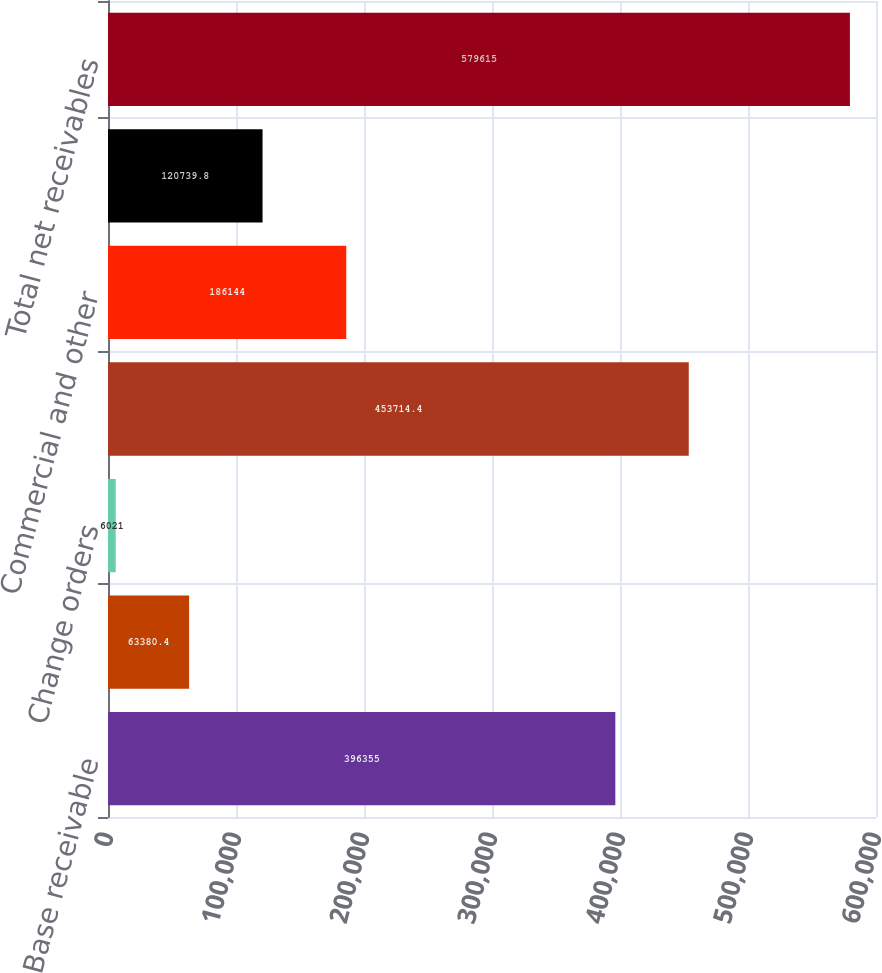<chart> <loc_0><loc_0><loc_500><loc_500><bar_chart><fcel>Base receivable<fcel>Bid price adjustments (BPAs)<fcel>Change orders<fcel>TRICARE subtotal<fcel>Commercial and other<fcel>Allowance for doubtful<fcel>Total net receivables<nl><fcel>396355<fcel>63380.4<fcel>6021<fcel>453714<fcel>186144<fcel>120740<fcel>579615<nl></chart> 